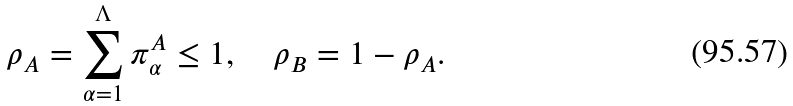Convert formula to latex. <formula><loc_0><loc_0><loc_500><loc_500>\rho _ { A } = \sum _ { \alpha = 1 } ^ { \Lambda } \pi _ { \alpha } ^ { A } \leq 1 , \quad \rho _ { B } = 1 - \rho _ { A } .</formula> 